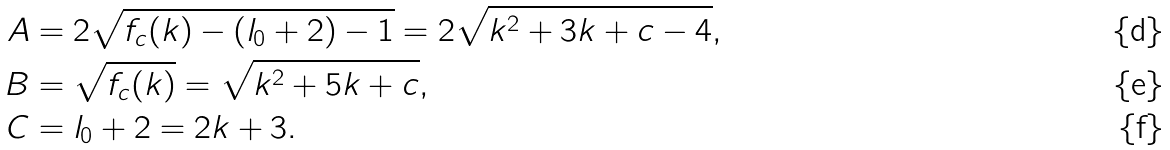<formula> <loc_0><loc_0><loc_500><loc_500>A & = 2 \sqrt { f _ { c } ( k ) - ( l _ { 0 } + 2 ) - 1 } = 2 \sqrt { k ^ { 2 } + 3 k + c - 4 } , \\ B & = \sqrt { f _ { c } ( k ) } = \sqrt { k ^ { 2 } + 5 k + c } , \\ C & = l _ { 0 } + 2 = 2 k + 3 .</formula> 